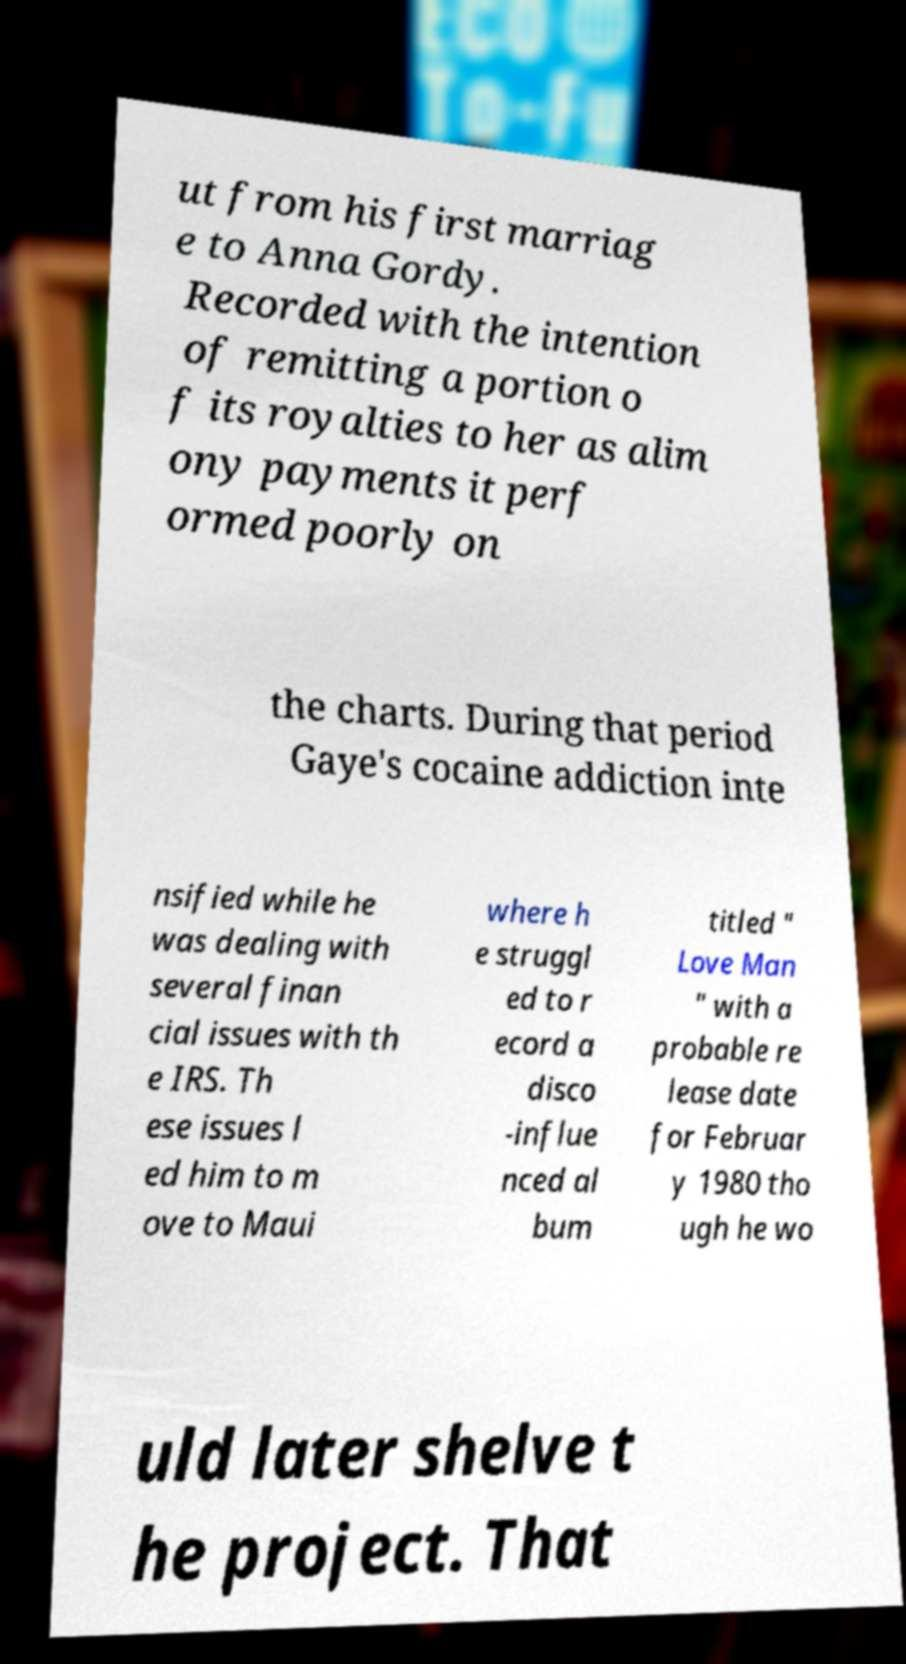Can you read and provide the text displayed in the image?This photo seems to have some interesting text. Can you extract and type it out for me? ut from his first marriag e to Anna Gordy. Recorded with the intention of remitting a portion o f its royalties to her as alim ony payments it perf ormed poorly on the charts. During that period Gaye's cocaine addiction inte nsified while he was dealing with several finan cial issues with th e IRS. Th ese issues l ed him to m ove to Maui where h e struggl ed to r ecord a disco -influe nced al bum titled " Love Man " with a probable re lease date for Februar y 1980 tho ugh he wo uld later shelve t he project. That 